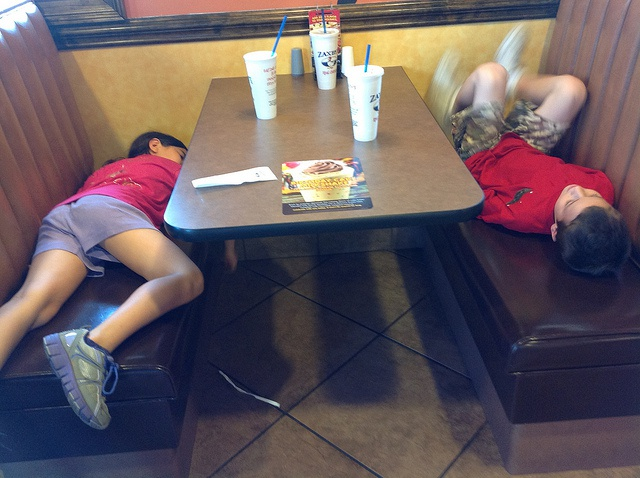Describe the objects in this image and their specific colors. I can see couch in white, black, and gray tones, dining table in white, tan, darkgray, gray, and navy tones, couch in white, navy, brown, and purple tones, chair in white, black, and gray tones, and people in white, darkgray, gray, and tan tones in this image. 